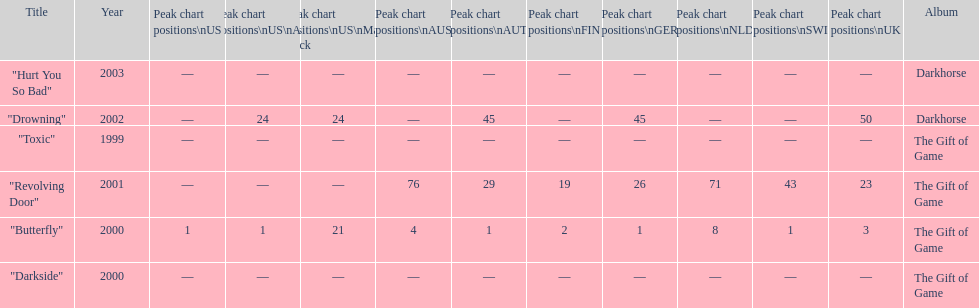When did "drowning" peak at 24 in the us alternate group? 2002. 